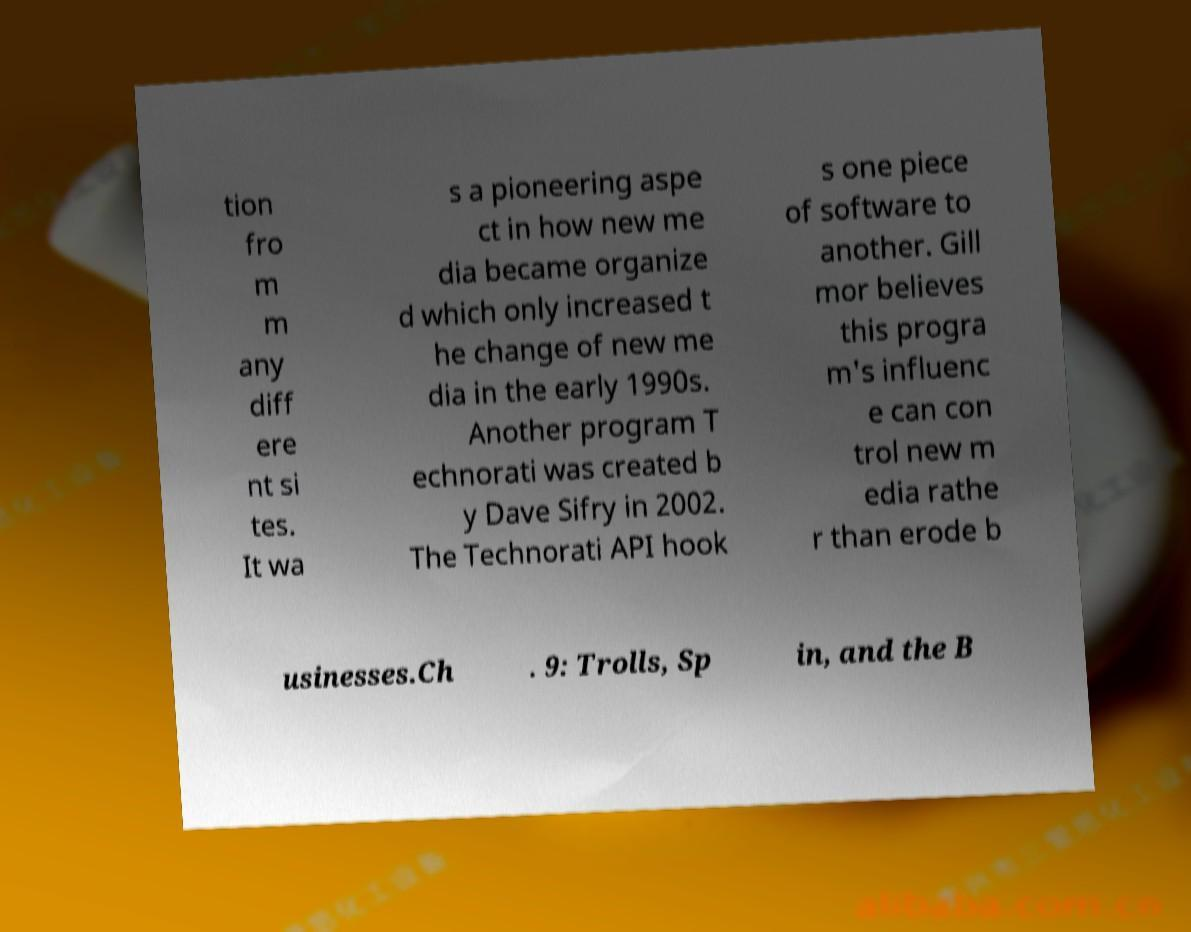Could you assist in decoding the text presented in this image and type it out clearly? tion fro m m any diff ere nt si tes. It wa s a pioneering aspe ct in how new me dia became organize d which only increased t he change of new me dia in the early 1990s. Another program T echnorati was created b y Dave Sifry in 2002. The Technorati API hook s one piece of software to another. Gill mor believes this progra m's influenc e can con trol new m edia rathe r than erode b usinesses.Ch . 9: Trolls, Sp in, and the B 